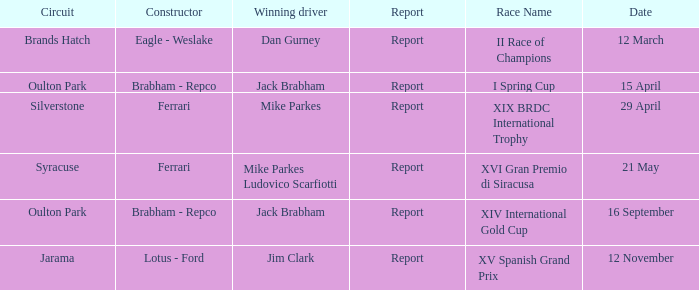What date was the xiv international gold cup? 16 September. 